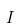Convert formula to latex. <formula><loc_0><loc_0><loc_500><loc_500>I</formula> 